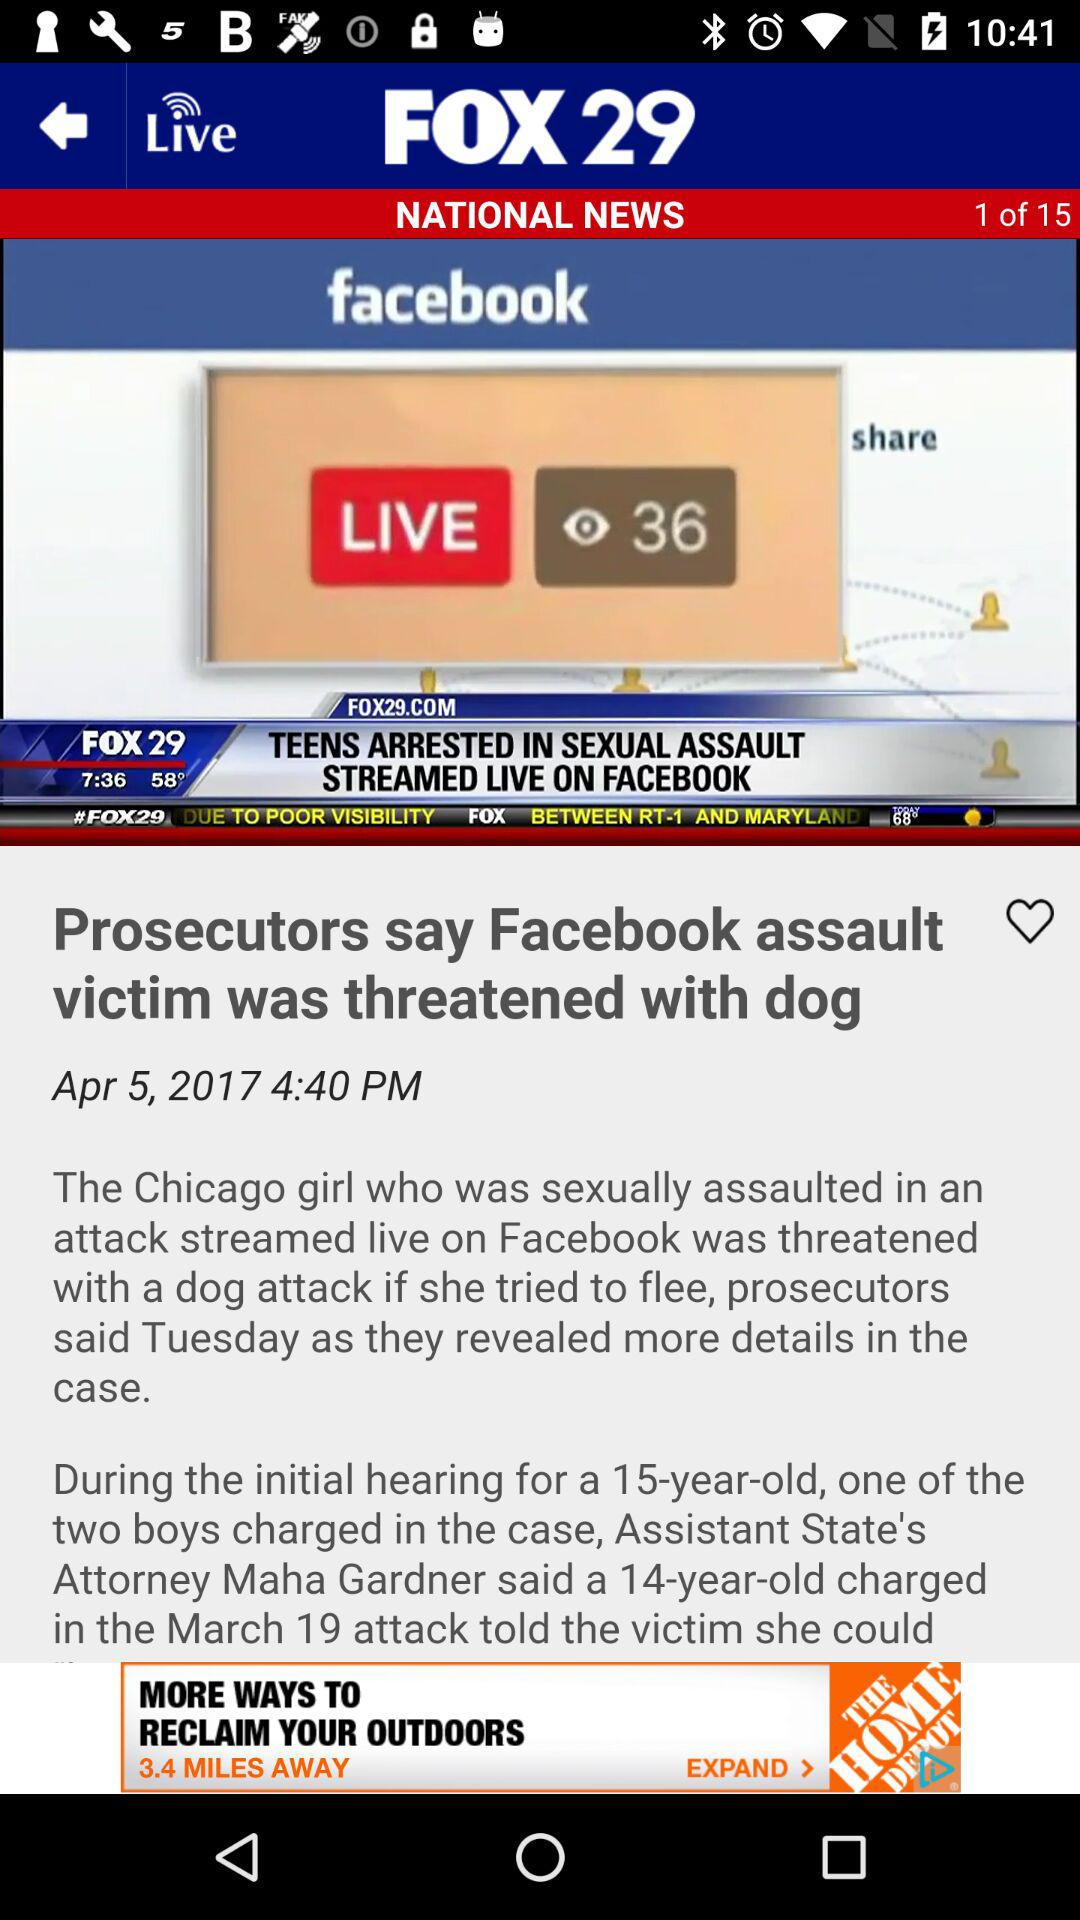What is the time of news? The news time is 4:40 PM. 